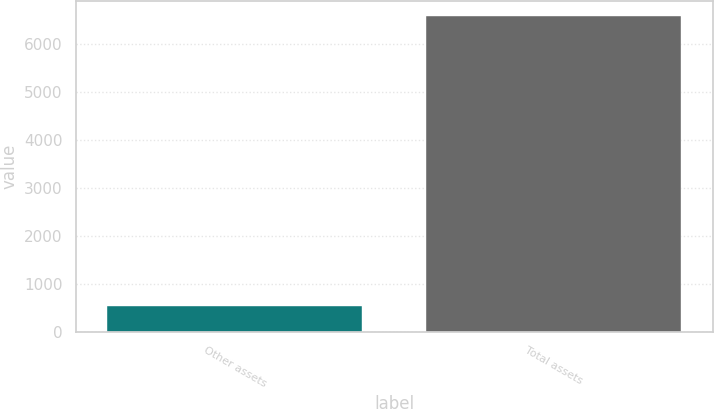Convert chart. <chart><loc_0><loc_0><loc_500><loc_500><bar_chart><fcel>Other assets<fcel>Total assets<nl><fcel>536<fcel>6583<nl></chart> 